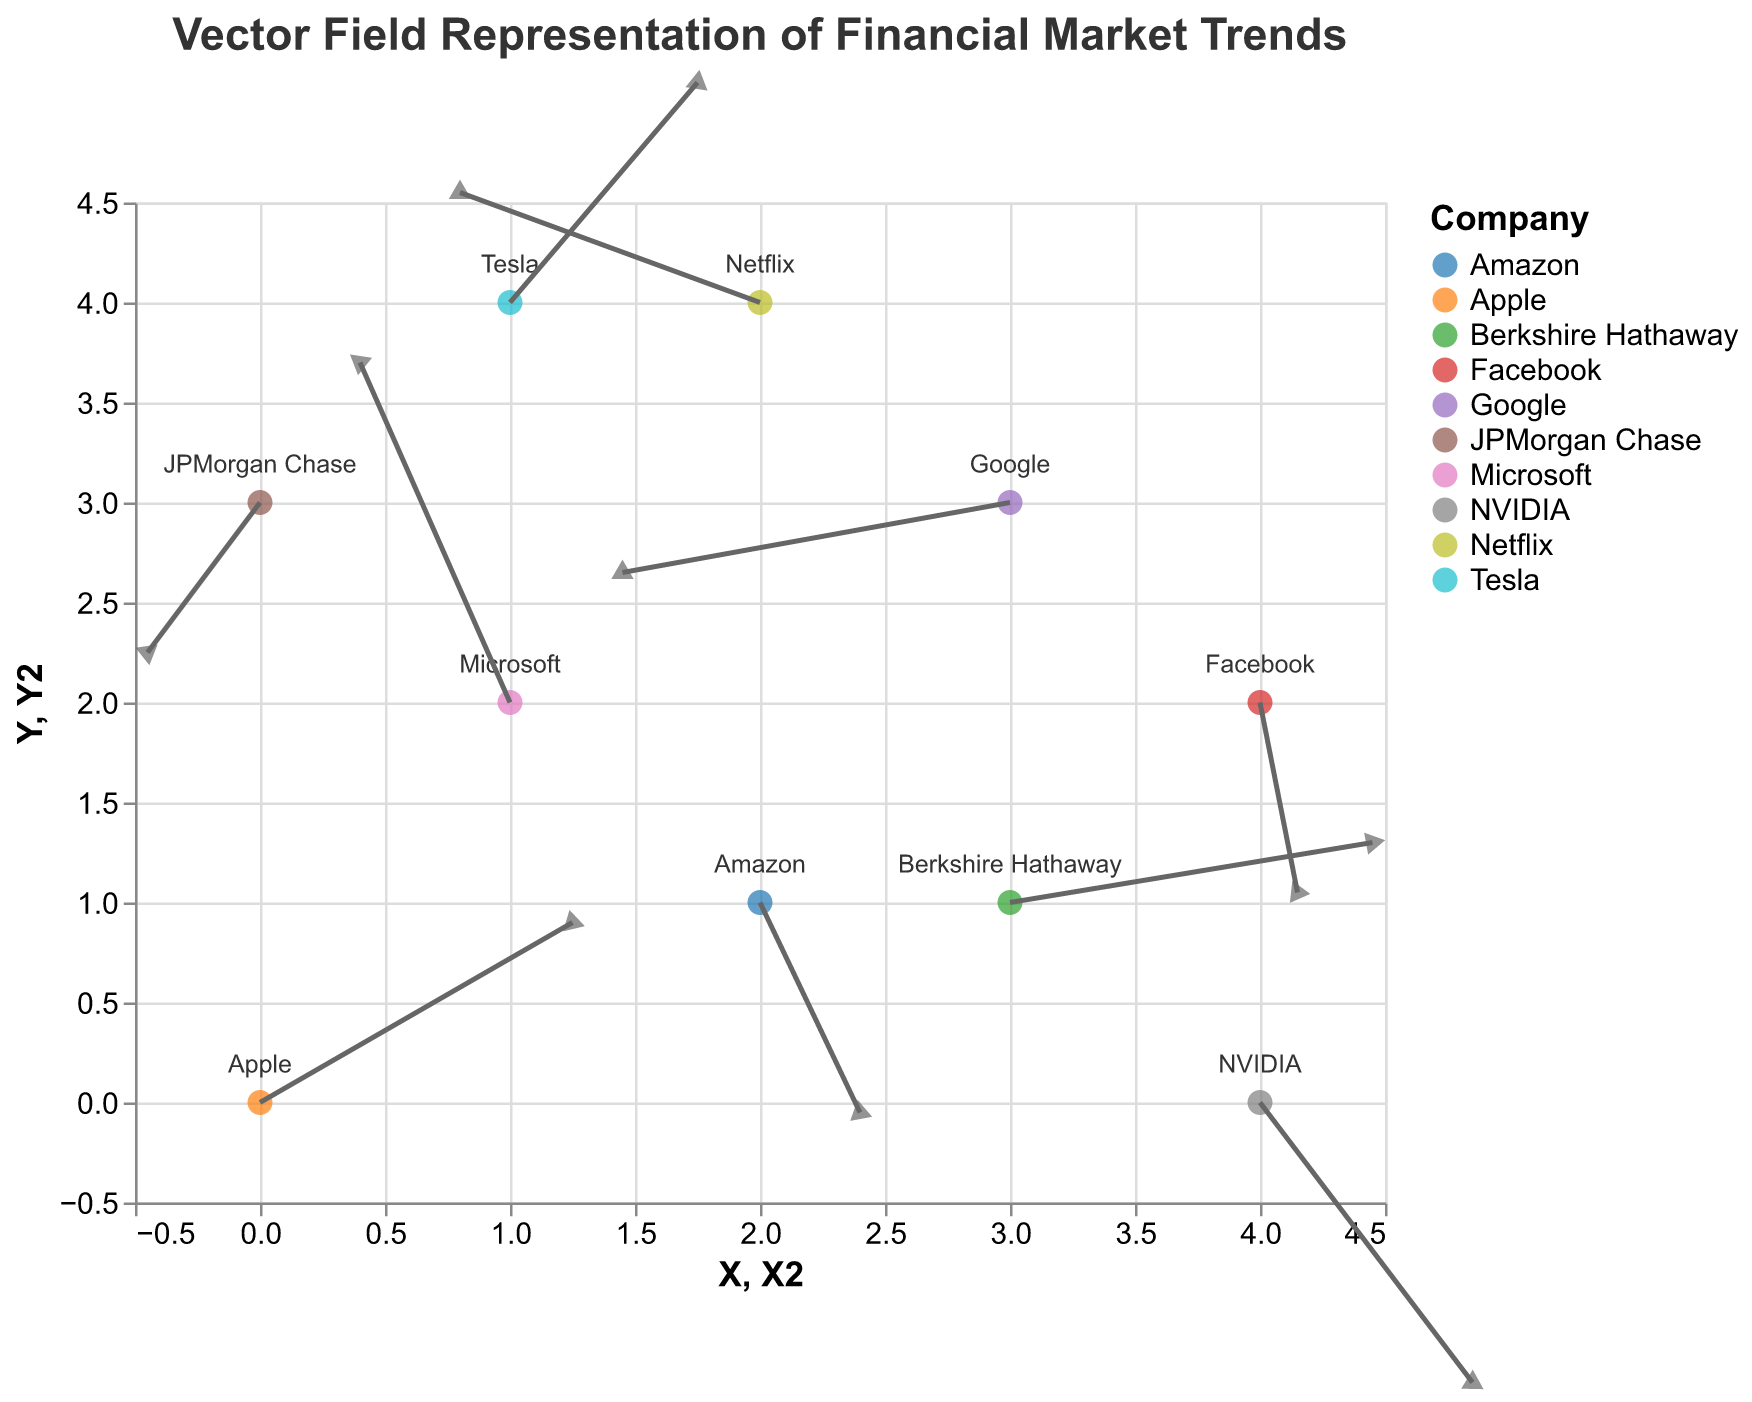What is the title of the figure? The title is usually found at the top of the figure, providing a summary of what the figure represents. In this case, the title should give an idea about the content related to financial markets.
Answer: Vector Field Representation of Financial Market Trends Which company has the point positioned at (2, 4)? By looking at the coordinates on the X and Y axes, we find the point where X is 2 and Y is 4. The associated company label there is "Netflix."
Answer: Netflix What is the color used to represent Berkshire Hathaway? Colors are used to code the companies. By locating Berkshire Hathaway on the plot and observing its visual representation, we can determine the associated color.
Answer: Blue (assuming color scheme) What is the magnitude of the vector for Tesla? The magnitude of a vector can be calculated using the formula sqrt(U^2 + V^2). For Tesla, with U = 1.5 and V = 2.2, the magnitude is sqrt(1.5^2 + 2.2^2) ≈ 2.7.
Answer: 2.7 Which companies have vectors pointing downward (negative V)? To determine this, we look for vectors where the V component is negative, indicating a downward direction. Amazon, Google, Facebook, NVIDIA, and JPMorgan Chase have negative V values.
Answer: Amazon, Google, Facebook, NVIDIA, JPMorgan Chase Which company has the vector with the largest magnitude? The magnitude is calculated by sqrt(U^2 + V^2). We compare the magnitudes of all vectors to find the largest one. Tesla has the vector with the largest magnitude (≈ 2.7).
Answer: Tesla What is the average X position of all points? To find the average X position, sum the X coordinates of all points and divide by the number of points: (0 + 1 + 2 + 3 + 1 + 4 + 2 + 4 + 0 + 3) / 10 = 20 / 10 = 2.
Answer: 2 Between Apple and Microsoft, which company has a higher Y position? Apple is at (0, 0) and Microsoft is at (1, 2). Comparing the Y positions, Microsoft (Y = 2) is higher than Apple (Y = 0).
Answer: Microsoft How many companies have vectors with a positive U component? To count the vectors with a positive U component, we look for vectors where U is greater than 0. Apple, Amazon, Tesla, Facebook, NVIDIA, Berkshire Hathaway – 6 companies.
Answer: 6 What is the direction (angle) of Google's vector? The direction of a vector can be calculated using atan2(V, U). For Google, V = -0.7, U = -3.1, the angle = atan2(-0.7, -3.1) in radians, converted to degrees ≈ -168.69°
Answer: -168.69° or approximately 191.31° from the positive X-axis 